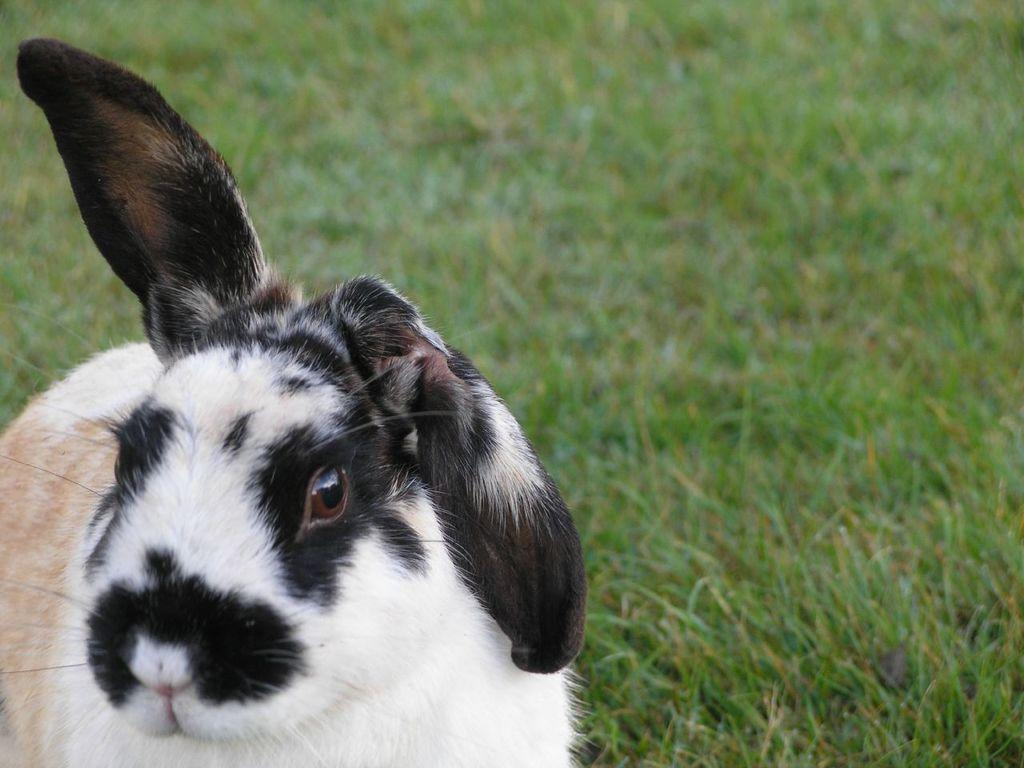What type of animal is in the image? The animal in the image is not specified, but it has black, white, and cream coloring. What is the animal standing on in the image? The animal is on the grass in the image. What type of vegetation is visible in the background of the image? There is grass visible in the background of the image. What type of coil is being used by the animal in the image? There is no coil present in the image; the animal is simply standing on the grass. Is there a club visible in the image? No, there is no club present in the image. 